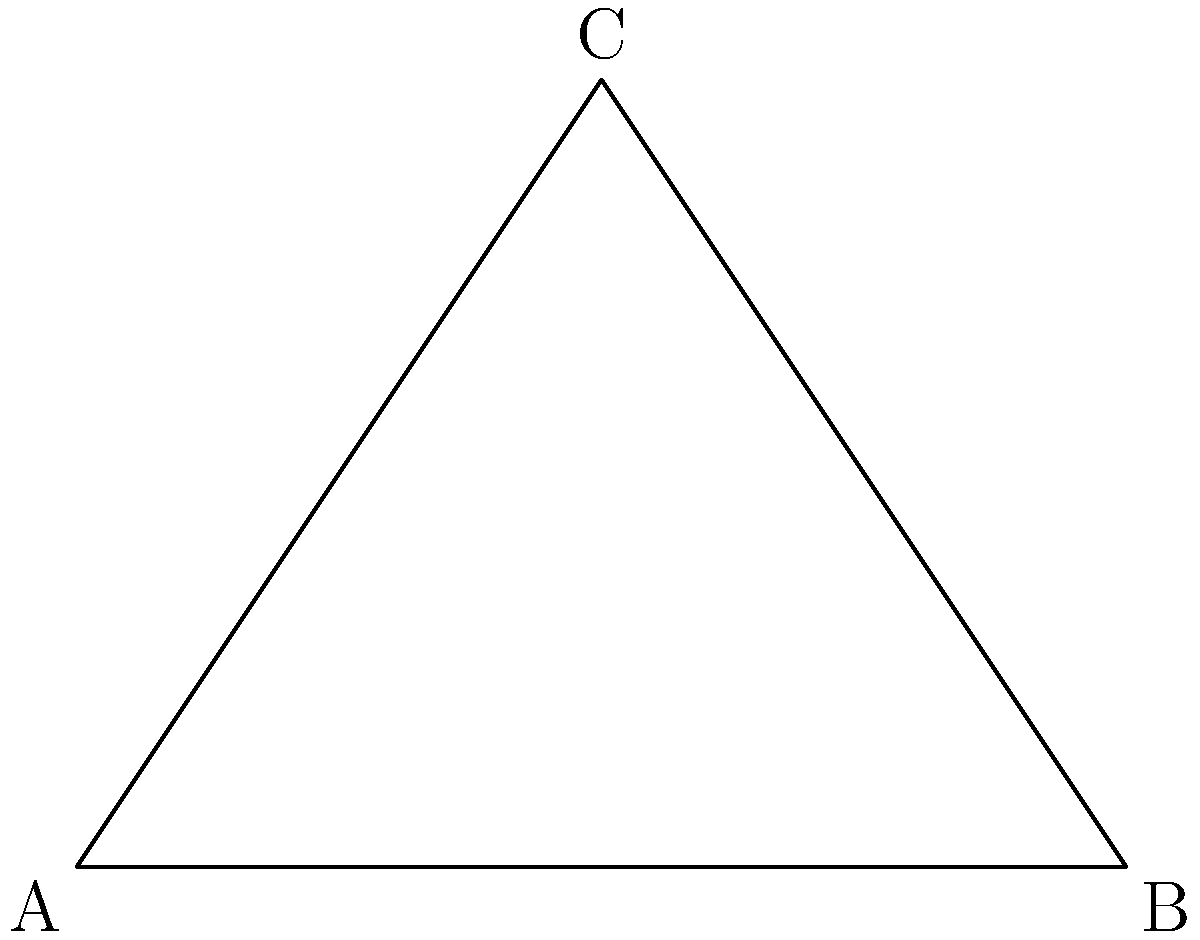The judge's gavel, when striking the sound block, forms a right-angled triangle as shown in the diagram. The handle of the gavel forms the hypotenuse (AB), while the head of the gavel forms one of the other sides (AC). If the angle $\theta$ is 30°, what is the value of angle $\alpha$? Let's approach this step-by-step:

1) In a right-angled triangle, the sum of all angles is 180°.

2) We know that one angle is a right angle (90°), and another angle ($\theta$) is given as 30°.

3) Let's call the third angle $\alpha$.

4) We can set up an equation:
   
   $90° + 30° + \alpha = 180°$

5) Simplifying:
   
   $120° + \alpha = 180°$

6) Subtracting 120° from both sides:
   
   $\alpha = 180° - 120° = 60°$

Therefore, the value of angle $\alpha$ is 60°.
Answer: 60° 